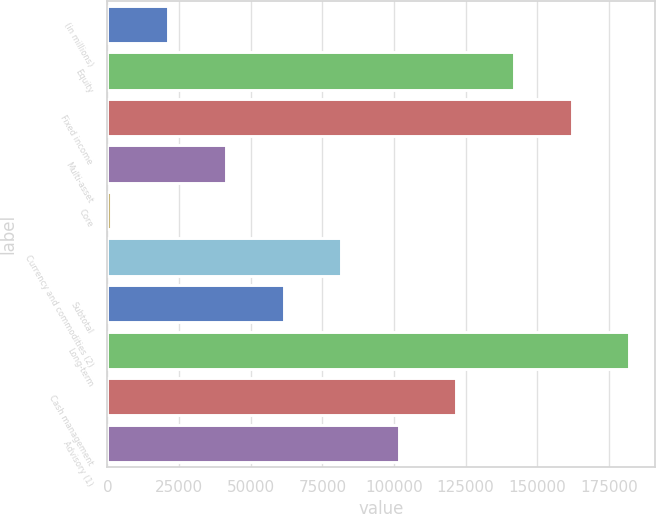<chart> <loc_0><loc_0><loc_500><loc_500><bar_chart><fcel>(in millions)<fcel>Equity<fcel>Fixed income<fcel>Multi-asset<fcel>Core<fcel>Currency and commodities (2)<fcel>Subtotal<fcel>Long-term<fcel>Cash management<fcel>Advisory (1)<nl><fcel>21267.6<fcel>141883<fcel>161986<fcel>41370.2<fcel>1165<fcel>81575.4<fcel>61472.8<fcel>182088<fcel>121781<fcel>101678<nl></chart> 